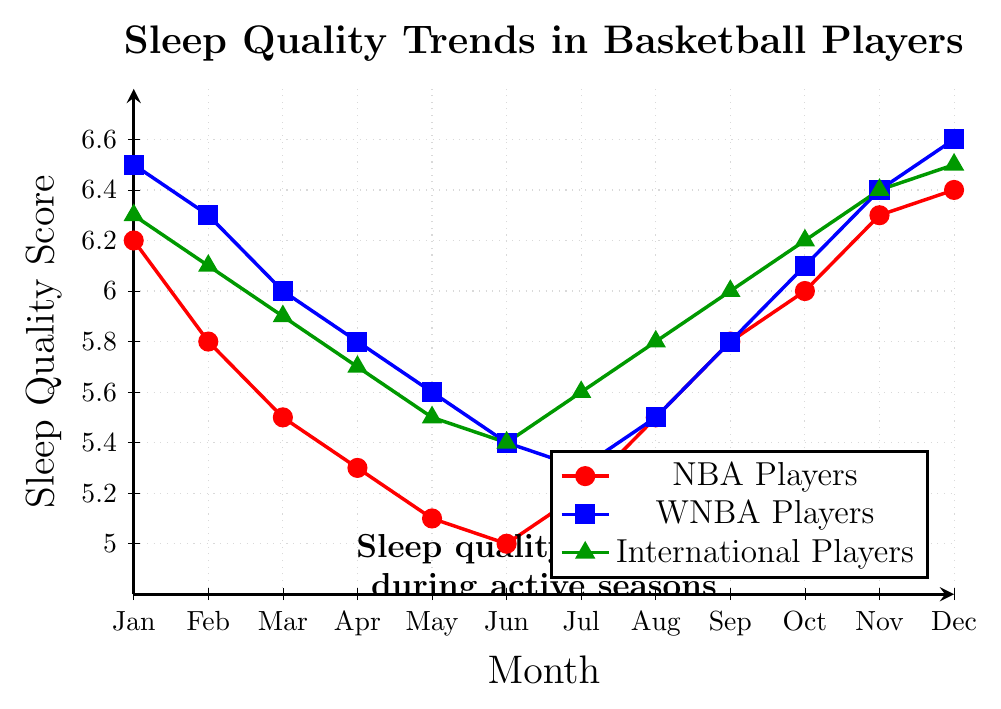Which group of players has the highest sleep quality score in January? The red line represents NBA players, the blue line represents WNBA players, and the green line represents International players. In January, the blue line (WNBA players) is the highest at 6.5.
Answer: WNBA Players How does the sleep quality of NBA players change from June to July? The red line represents NBA players. In June, the sleep quality score is 5.0, and in July, it rises to 5.2. The sleep quality improves by 0.2 points.
Answer: It increases by 0.2 Between which months do WNBA players show the greatest improvement in sleep quality? To find the greatest improvement, look at the largest positive change in the blue line's values month-by-month. From July (5.3) to August (5.5), the sleep quality increases by 0.2. From September (5.8) to October (6.1), the sleep quality increases by 0.3, which is the largest positive change.
Answer: September to October Which group of players shows the smallest range in sleep quality scores throughout the year? The range is the difference between the highest and lowest values for each group. NBA: 6.4 - 5.0 = 1.4, WNBA: 6.6 - 5.3 = 1.3, International: 6.5 - 5.4 = 1.1. The smallest range is 1.1 for International players.
Answer: International Players During which months is the sleep quality of NBA players lower than that of WNBA and International players? Compare red line (NBA) to blue (WNBA) and green (International) lines for each month where the red line is below both. This occurs in May, June, July, August, September, and October.
Answer: May, June, July, August, September, October What is the average sleep quality for International players from January to March? Sleep quality scores for International players are 6.3 (Jan), 6.1 (Feb), and 5.9 (Mar). The average is calculated as (6.3 + 6.1 + 5.9) / 3 = 18.3 / 3 = 6.1.
Answer: 6.1 For each group, during which month is the lowest sleep quality score observed? Identify the lowest point on each line: NBA in June (5.0), WNBA in July (5.3), and International in June (5.4).
Answer: NBA: June, WNBA: July, International: June What is the difference in sleep quality scores between January and April for WNBA players? In January, the sleep quality score is 6.5, and in April, it is 5.8. The difference is 6.5 - 5.8 = 0.7.
Answer: 0.7 Comparing the highest sleep quality scores among all players, which month has the highest overall score? The highest individual scores for each month are checked: WNBA in December has the highest overall score at 6.6.
Answer: December 